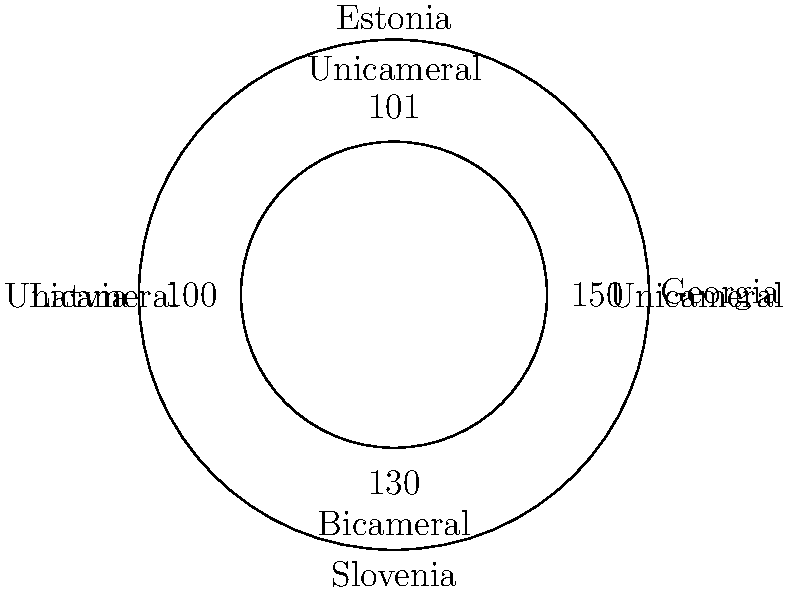Based on the circular hierarchy diagram comparing the legislative structures of small states, which country stands out as having a different parliamentary system compared to the others, and how many seats does its legislature have? To answer this question, we need to analyze the information provided in the circular hierarchy diagram:

1. The diagram shows four countries: Georgia, Estonia, Latvia, and Slovenia.
2. For each country, it provides information on their legislative structure (Unicameral or Bicameral) and the number of seats in their legislature.
3. Let's examine each country:
   - Georgia: Unicameral, 150 seats
   - Estonia: Unicameral, 101 seats
   - Latvia: Unicameral, 100 seats
   - Slovenia: Bicameral, 130 seats

4. Among these four countries, Slovenia stands out as having a different parliamentary system. While Georgia, Estonia, and Latvia have unicameral legislatures, Slovenia has a bicameral legislature.
5. The number of seats in Slovenia's legislature is 130.

Therefore, Slovenia is the country with a different parliamentary system (bicameral), and its legislature has 130 seats.
Answer: Slovenia, 130 seats 